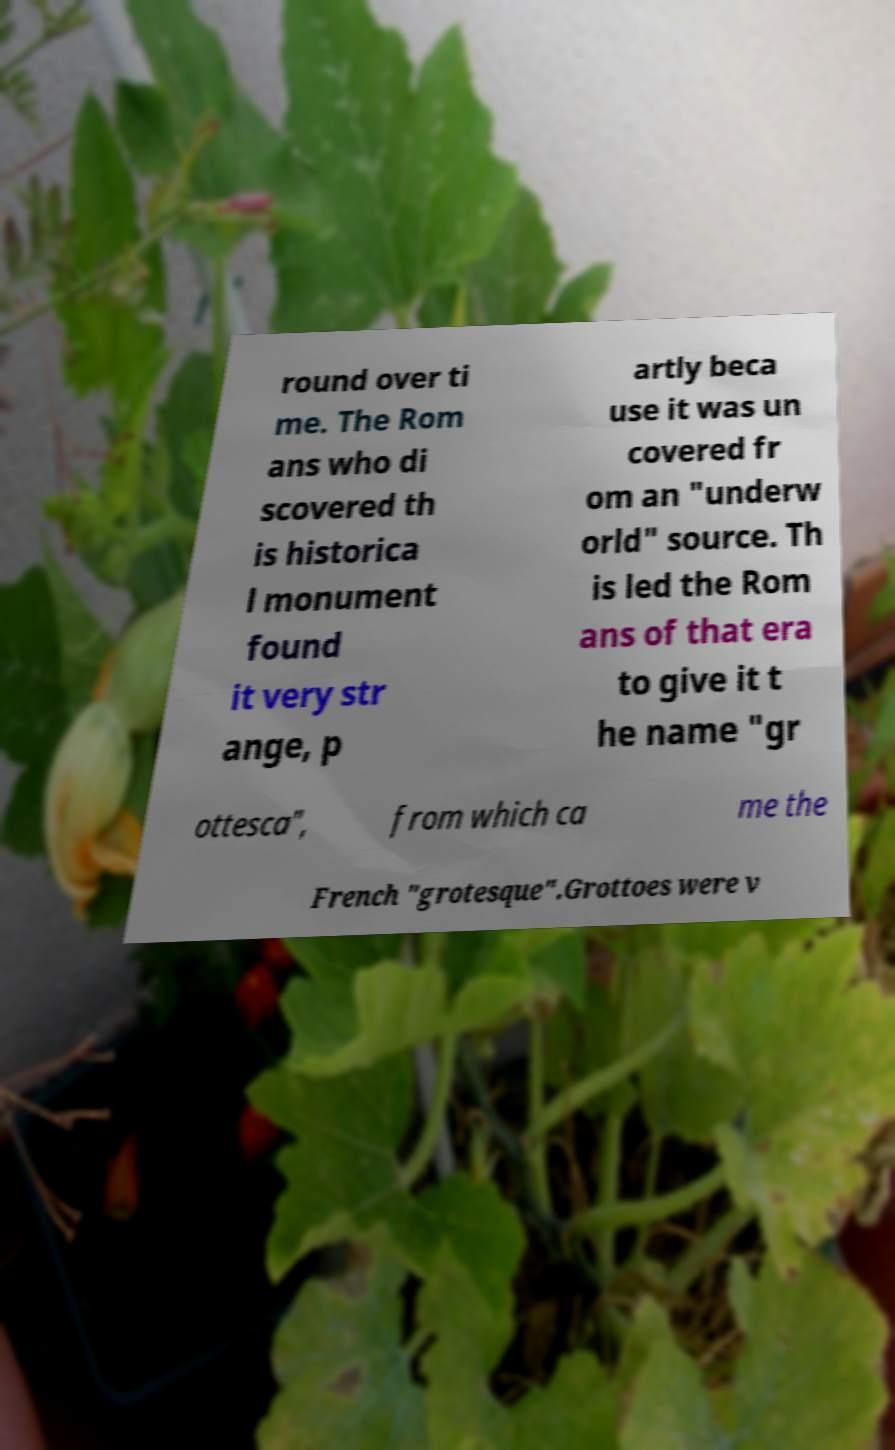There's text embedded in this image that I need extracted. Can you transcribe it verbatim? round over ti me. The Rom ans who di scovered th is historica l monument found it very str ange, p artly beca use it was un covered fr om an "underw orld" source. Th is led the Rom ans of that era to give it t he name "gr ottesca", from which ca me the French "grotesque".Grottoes were v 